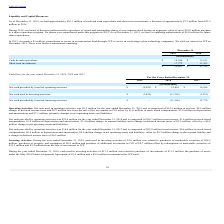From Finjan Holding's financial document, What is the amount of cash and cash equivalents had by the company in 2018 and 2019 respectively? The document shows two values: $43.3 million and $36.1 million. From the document: "nts, a decrease of approximately $7.2 million from $43.3 million in 2018. As of December 31, 2019, we had approximately $36.1 million of cash and cash..." Also, What is the amount authorised to be spent on the share repurchase program in 2018 and what is the remaining authorization in 2019? The document shows two values: $10.0 million and $8.0 million. From the document: "ur common stock having an aggregate value of up to $10.0 million pursuant to a share repurchase program. No shares were repurchased under this program..." Also, What are the respective cash & cash equivalents held by the company in 2018 and 2019 respectively? The document shows two values: 32,011 and 18,304 (in thousands). From the document: "Cash & cash equivalents $ 18,304 $ 32,011 Cash & cash equivalents $ 18,304 $ 32,011..." Also, can you calculate: What is the percentage change in the cash & cash equivalents between 2018 and 2019? To answer this question, I need to perform calculations using the financial data. The calculation is: (18,304 - 32,011)/32,011 , which equals -42.82 (percentage). This is based on the information: "Cash & cash equivalents $ 18,304 $ 32,011 Cash & cash equivalents $ 18,304 $ 32,011..." The key data points involved are: 18,304, 32,011. Also, can you calculate: What is the percentage change in the short term investments between 2018 and 2019? To answer this question, I need to perform calculations using the financial data. The calculation is: (17,779 - 11,303)/11,303 , which equals 57.29 (percentage). This is based on the information: "Short term investments 17,779 11,303 Short term investments 17,779 11,303..." The key data points involved are: 11,303, 17,779. Also, can you calculate: What is the percentage change in the total liquidity and capital resources between 2018 and 2019? To answer this question, I need to perform calculations using the financial data. The calculation is: (36,083 - 43,314)/43,314 , which equals -16.69 (percentage). This is based on the information: "$ 36,083 $ 43,314 $ 36,083 $ 43,314..." The key data points involved are: 36,083, 43,314. 